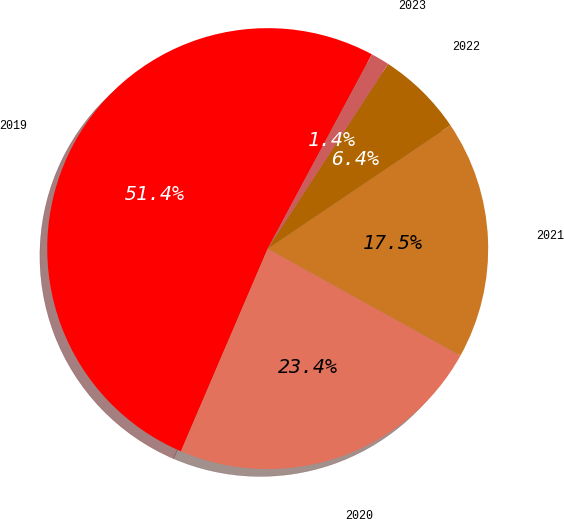Convert chart. <chart><loc_0><loc_0><loc_500><loc_500><pie_chart><fcel>2019<fcel>2020<fcel>2021<fcel>2022<fcel>2023<nl><fcel>51.4%<fcel>23.38%<fcel>17.51%<fcel>6.36%<fcel>1.36%<nl></chart> 